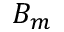<formula> <loc_0><loc_0><loc_500><loc_500>B _ { m }</formula> 